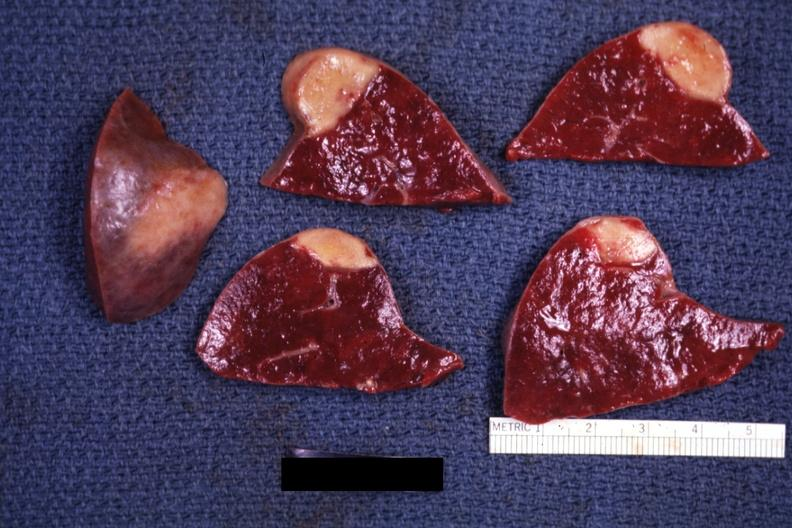what does this image show?
Answer the question using a single word or phrase. Several slices with obvious lesion and one external view excellent example 